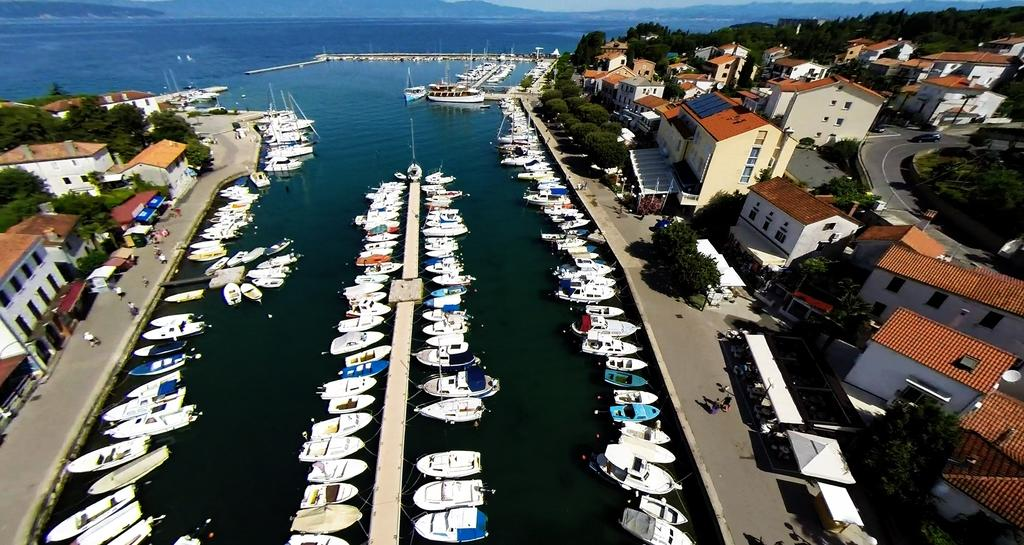What is floating on the water in the image? There are boats floating on the water in the image. What type of vegetation can be seen in the image? Trees are visible in the image. What type of structures are present in the image? Buildings are present in the image. What can be seen on the right side of the image? There is a road on the right side of the image. What is visible at the top of the image? The sky is visible at the top of the image. Where are the pets located in the image? There are no pets present in the image. What type of wall is visible in the image? There is no wall visible in the image. 